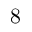Convert formula to latex. <formula><loc_0><loc_0><loc_500><loc_500>8</formula> 